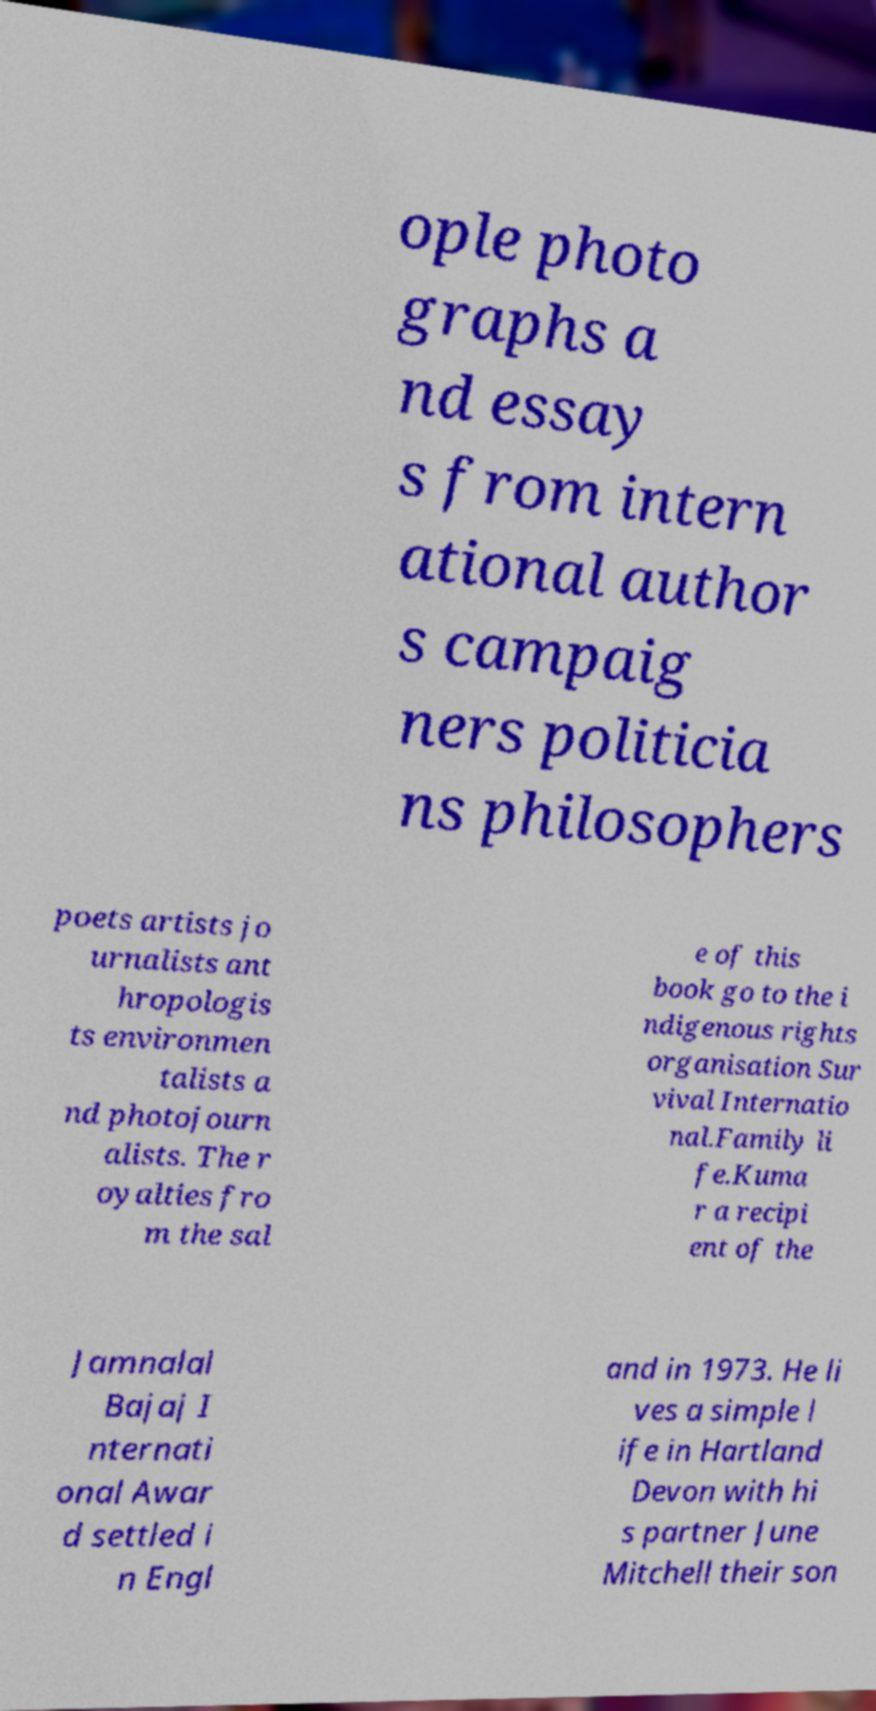Please read and relay the text visible in this image. What does it say? ople photo graphs a nd essay s from intern ational author s campaig ners politicia ns philosophers poets artists jo urnalists ant hropologis ts environmen talists a nd photojourn alists. The r oyalties fro m the sal e of this book go to the i ndigenous rights organisation Sur vival Internatio nal.Family li fe.Kuma r a recipi ent of the Jamnalal Bajaj I nternati onal Awar d settled i n Engl and in 1973. He li ves a simple l ife in Hartland Devon with hi s partner June Mitchell their son 